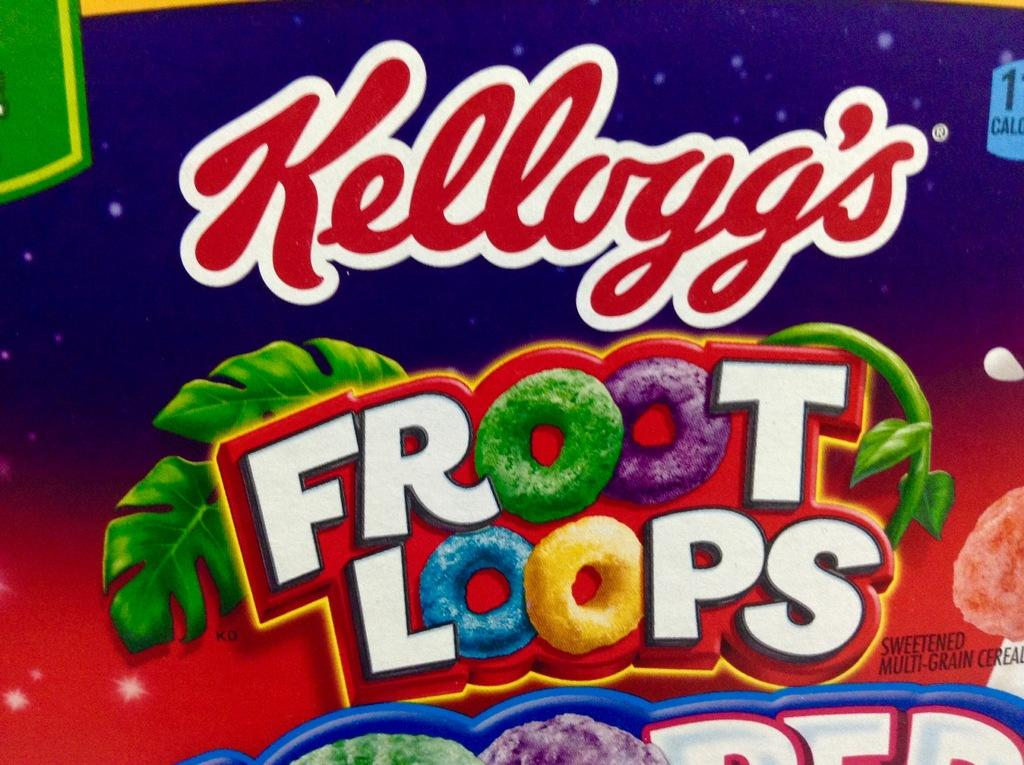What is the main object in the image? There is a box in the image. What is written on the box? The name "Kellogg's Fruit Loops" is written on the box. How would you describe the appearance of the box? The box is colorful. What type of wood is used to make the company logo on the box? There is no wood present in the image, as the box is made of cardboard and the logo is printed on it. 